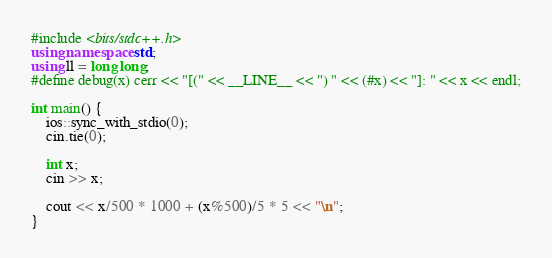Convert code to text. <code><loc_0><loc_0><loc_500><loc_500><_C++_>#include <bits/stdc++.h>
using namespace std;
using ll = long long;
#define debug(x) cerr << "[(" << __LINE__ << ") " << (#x) << "]: " << x << endl;

int main() {
    ios::sync_with_stdio(0);
    cin.tie(0);

    int x;
    cin >> x;

    cout << x/500 * 1000 + (x%500)/5 * 5 << "\n";
}
</code> 